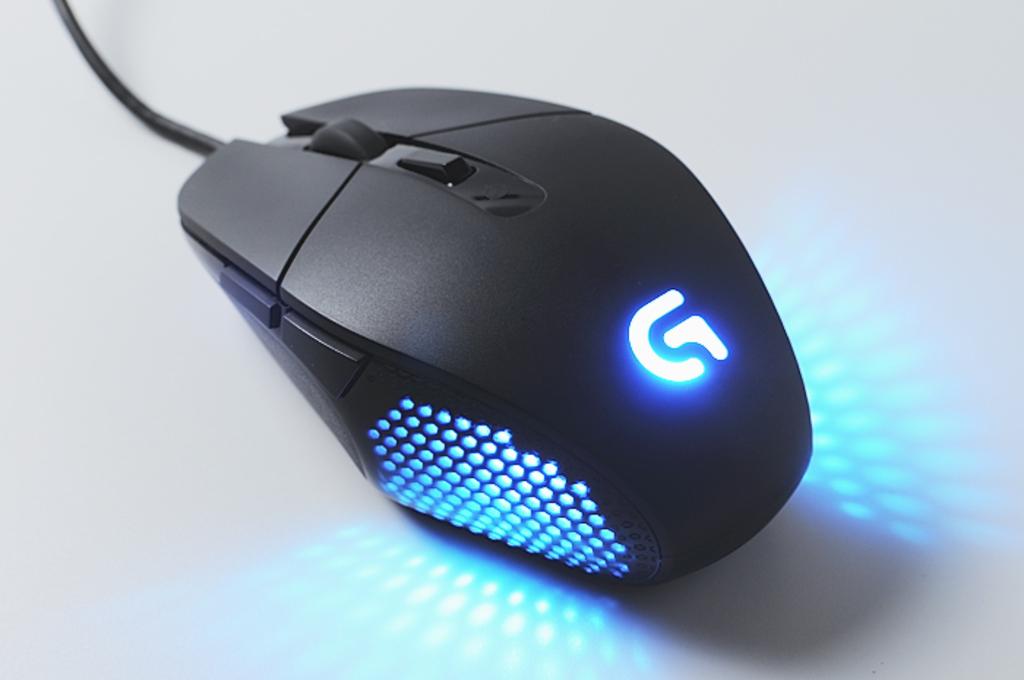What letter does the logo on the mouse look like?
Keep it short and to the point. G. 